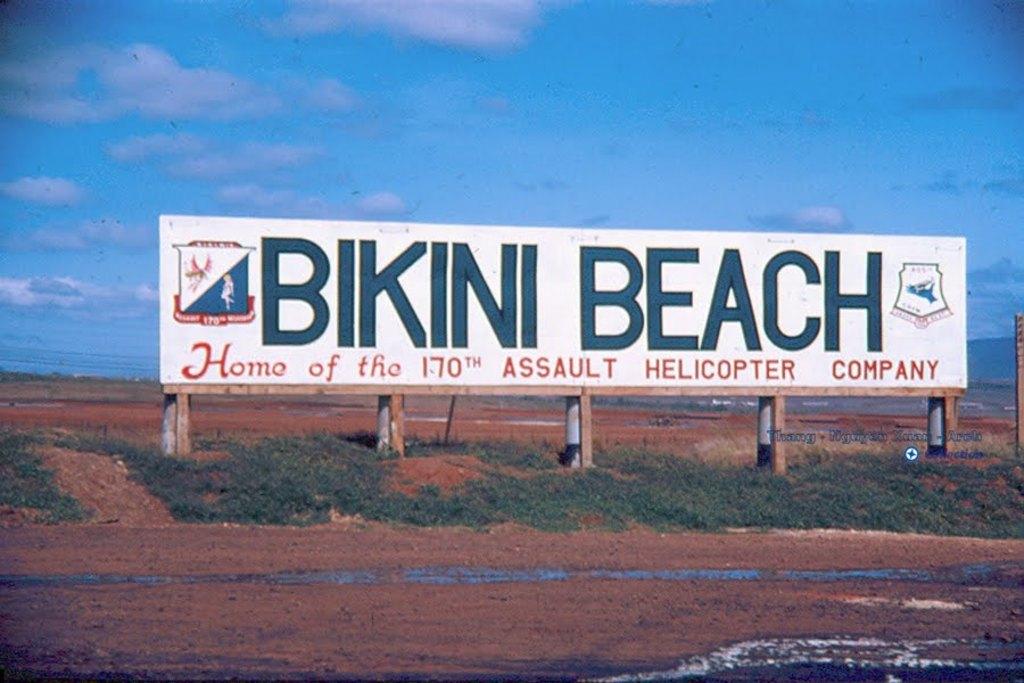What is bikini beach  the home of?
Your answer should be very brief. 170th assault helicopter company. What beach is this?
Your answer should be compact. Bikini beach. 